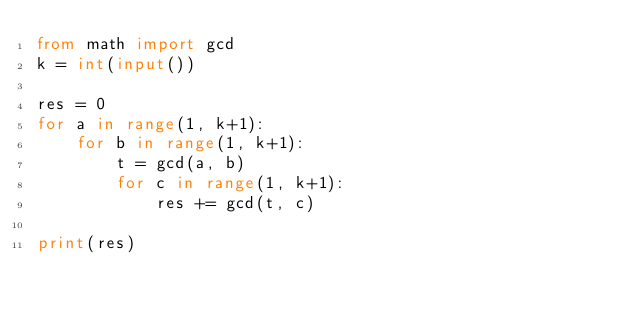<code> <loc_0><loc_0><loc_500><loc_500><_Python_>from math import gcd
k = int(input())

res = 0
for a in range(1, k+1):
    for b in range(1, k+1):
        t = gcd(a, b)
        for c in range(1, k+1):
            res += gcd(t, c)

print(res)
</code> 